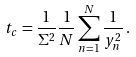Convert formula to latex. <formula><loc_0><loc_0><loc_500><loc_500>t _ { c } = \frac { 1 } { \Sigma ^ { 2 } } \frac { 1 } { N } \sum _ { n = 1 } ^ { N } \frac { 1 } { y _ { n } ^ { 2 } } \, .</formula> 